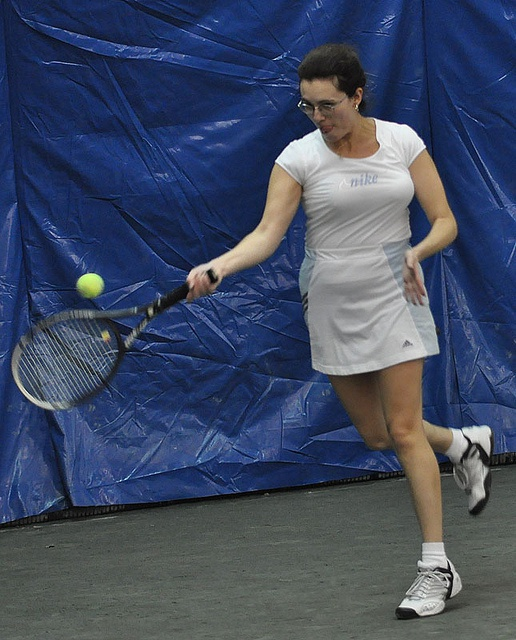Describe the objects in this image and their specific colors. I can see people in navy, darkgray, gray, and lightgray tones, tennis racket in navy, gray, black, and darkblue tones, and sports ball in navy, khaki, gray, and olive tones in this image. 